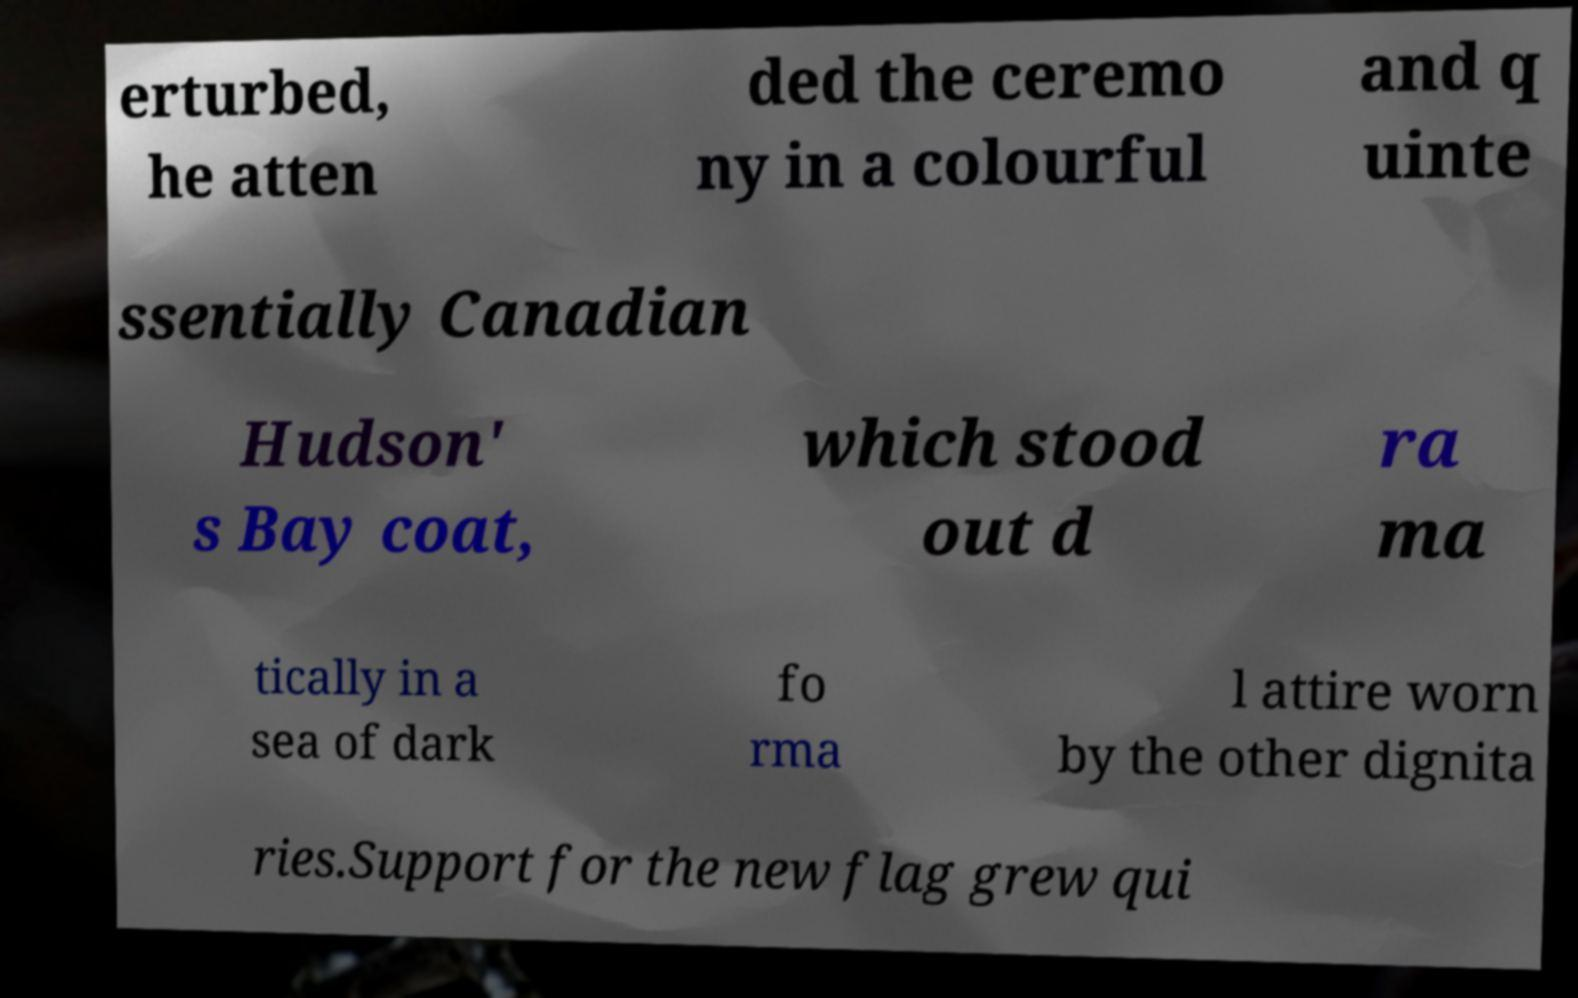Please read and relay the text visible in this image. What does it say? erturbed, he atten ded the ceremo ny in a colourful and q uinte ssentially Canadian Hudson' s Bay coat, which stood out d ra ma tically in a sea of dark fo rma l attire worn by the other dignita ries.Support for the new flag grew qui 